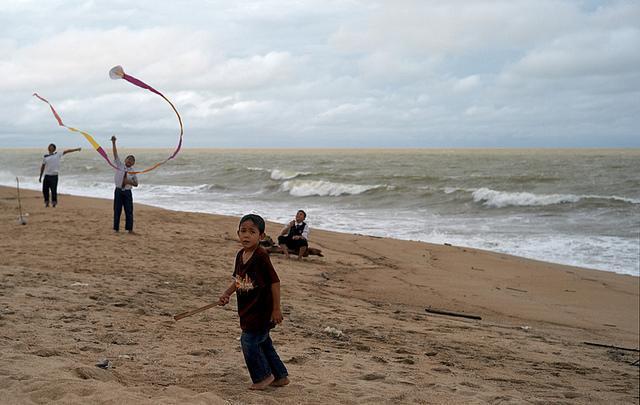How many people in the photo?
Give a very brief answer. 4. How many kids in the photo?
Give a very brief answer. 2. How many books on the hand are there?
Give a very brief answer. 0. 